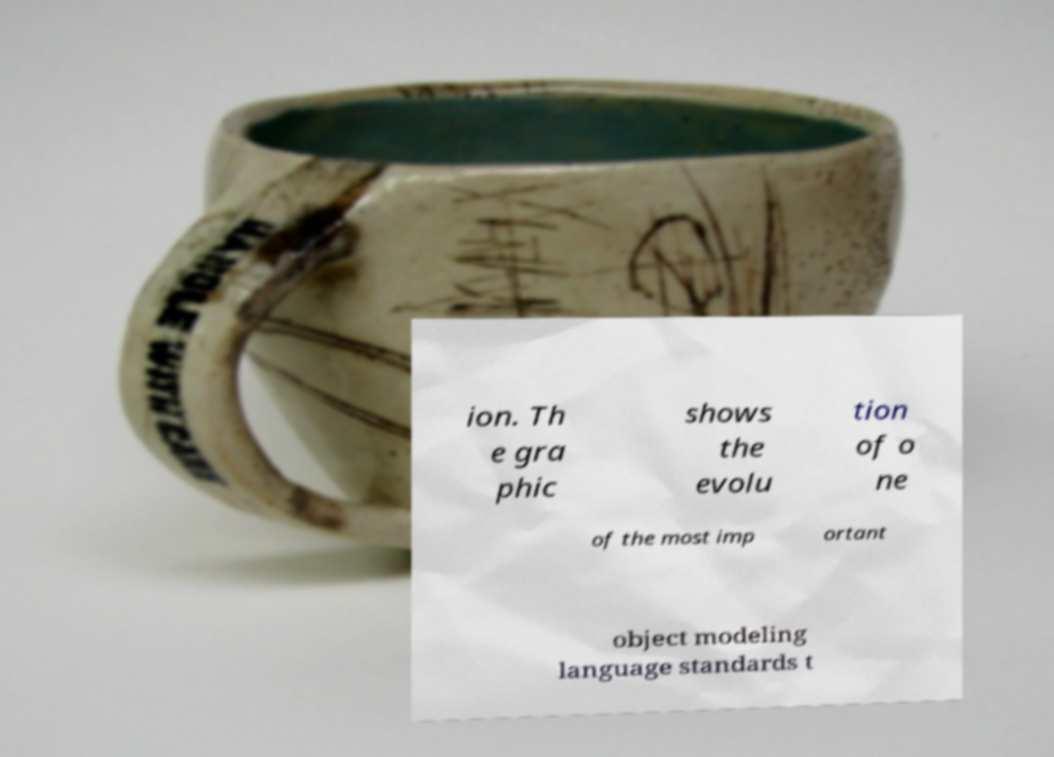Please read and relay the text visible in this image. What does it say? ion. Th e gra phic shows the evolu tion of o ne of the most imp ortant object modeling language standards t 